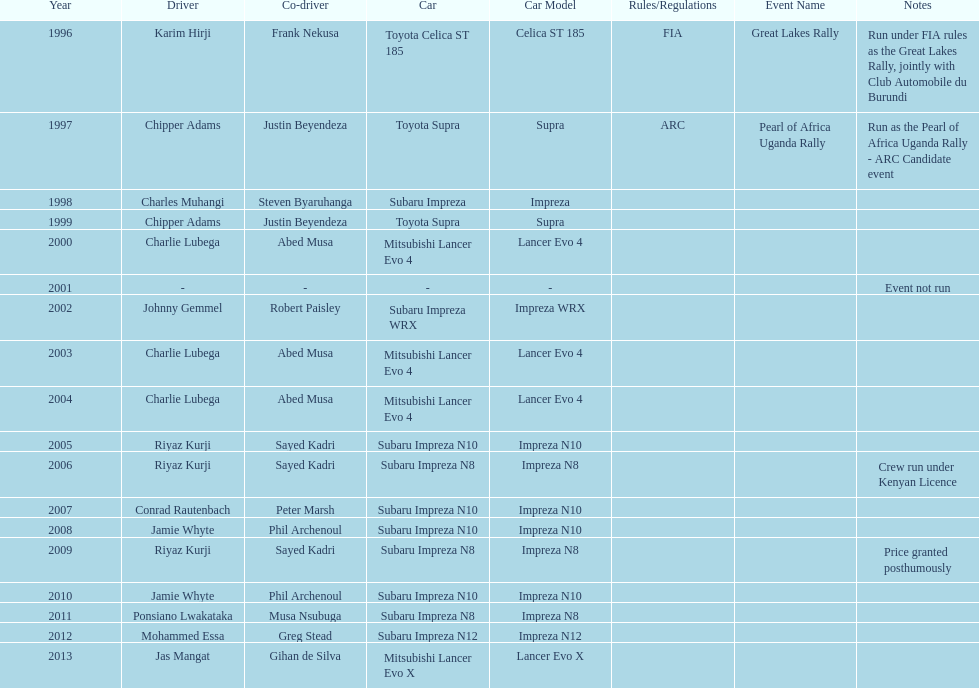Who was the only driver to win in a car other than a subaru impreza after the year 2005? Jas Mangat. 